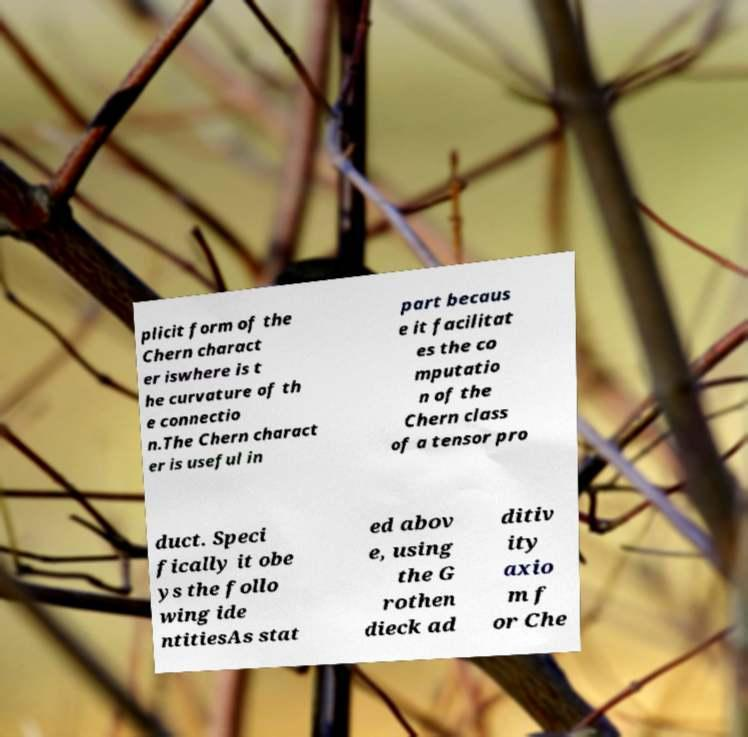For documentation purposes, I need the text within this image transcribed. Could you provide that? plicit form of the Chern charact er iswhere is t he curvature of th e connectio n.The Chern charact er is useful in part becaus e it facilitat es the co mputatio n of the Chern class of a tensor pro duct. Speci fically it obe ys the follo wing ide ntitiesAs stat ed abov e, using the G rothen dieck ad ditiv ity axio m f or Che 